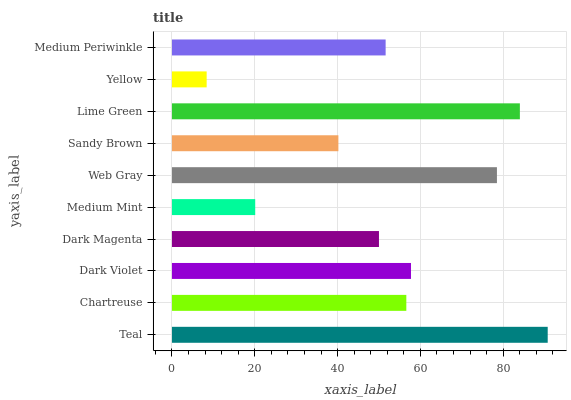Is Yellow the minimum?
Answer yes or no. Yes. Is Teal the maximum?
Answer yes or no. Yes. Is Chartreuse the minimum?
Answer yes or no. No. Is Chartreuse the maximum?
Answer yes or no. No. Is Teal greater than Chartreuse?
Answer yes or no. Yes. Is Chartreuse less than Teal?
Answer yes or no. Yes. Is Chartreuse greater than Teal?
Answer yes or no. No. Is Teal less than Chartreuse?
Answer yes or no. No. Is Chartreuse the high median?
Answer yes or no. Yes. Is Medium Periwinkle the low median?
Answer yes or no. Yes. Is Sandy Brown the high median?
Answer yes or no. No. Is Teal the low median?
Answer yes or no. No. 